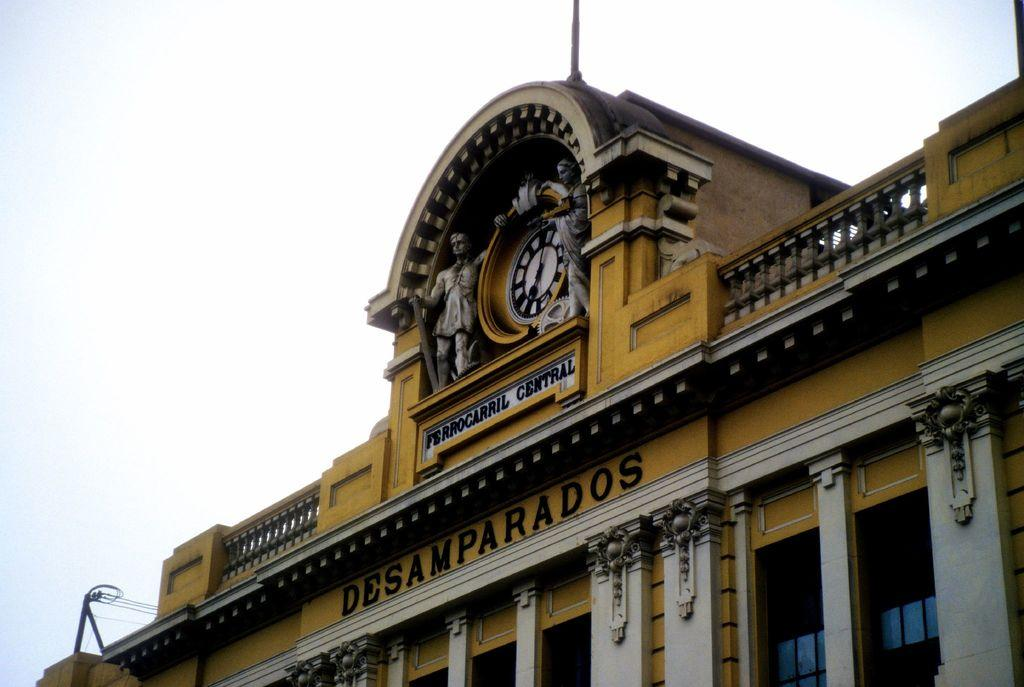<image>
Relay a brief, clear account of the picture shown. The Central railway in Desamparados, is a burnt, yellow color with concrete accents. 